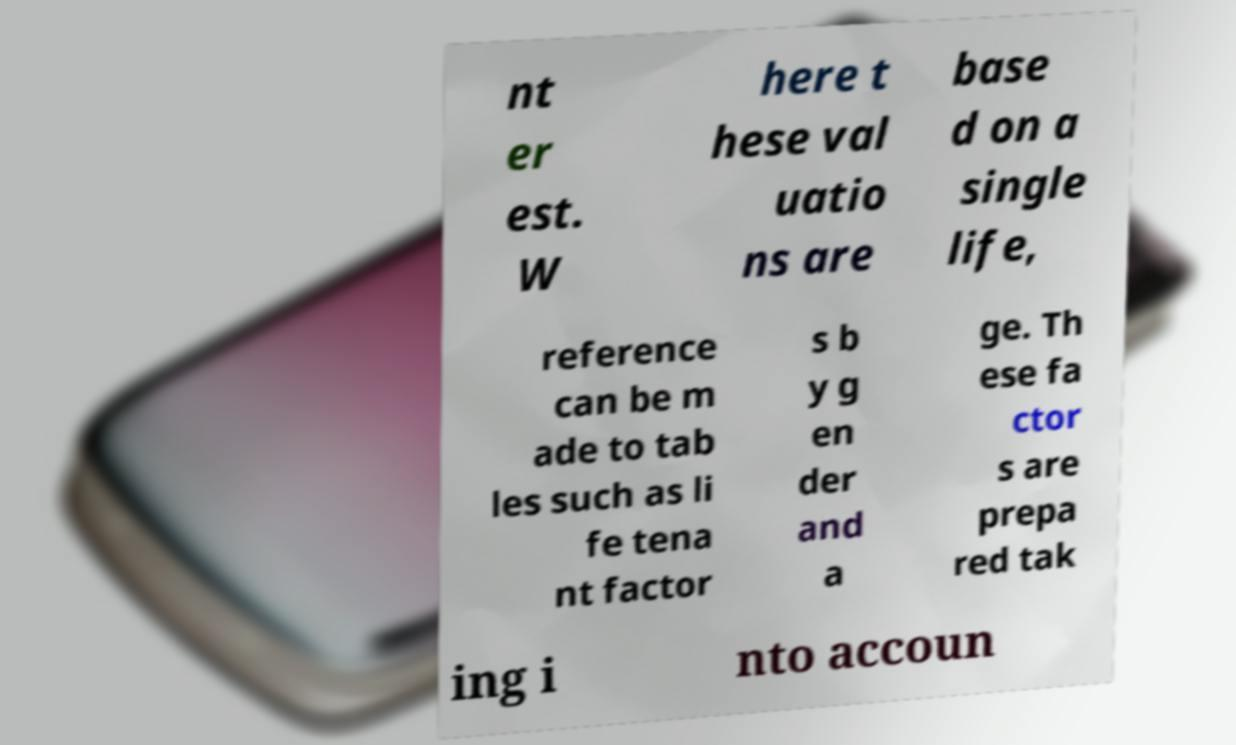I need the written content from this picture converted into text. Can you do that? nt er est. W here t hese val uatio ns are base d on a single life, reference can be m ade to tab les such as li fe tena nt factor s b y g en der and a ge. Th ese fa ctor s are prepa red tak ing i nto accoun 